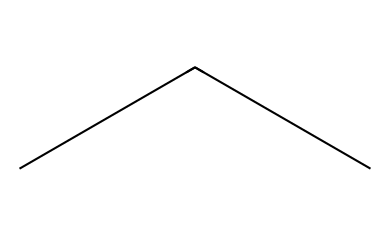What is the molecular formula of propane? The SMILES representation "CCC" indicates the presence of three carbon atoms (C) connected linearly, with hydrogen atoms filling the remaining valences, leading to the formula C3H8.
Answer: C3H8 How many carbon atoms are present in this molecule? The SMILES "CCC" reveals three carbon atoms arranged in a straight chain. Each 'C' represents one carbon atom.
Answer: 3 What type of chemical structure does propane have? The "CCC" representation shows a linear arrangement of carbon atoms with single bonds. This indicates that propane has an open-chain structure.
Answer: open-chain Is propane a natural refrigerant? Propane (R-290) is commonly recognized as a natural refrigerant used in some refrigeration systems, confirming its classification.
Answer: yes What is the saturated state of propane at room temperature? Propane is a gas at room temperature and pressure, consistent with its properties as a hydrocarbon with a low boiling point outside of refrigeration conditions.
Answer: gas How many hydrogen atoms are bonded to each carbon in propane? Each carbon in propane is bonded to a sufficient number of hydrogen atoms to satisfy the tetravalency of carbon; thus, in C3H8, two terminal carbons have three hydrogens each, and the central carbon has two, totaling eight.
Answer: 8 